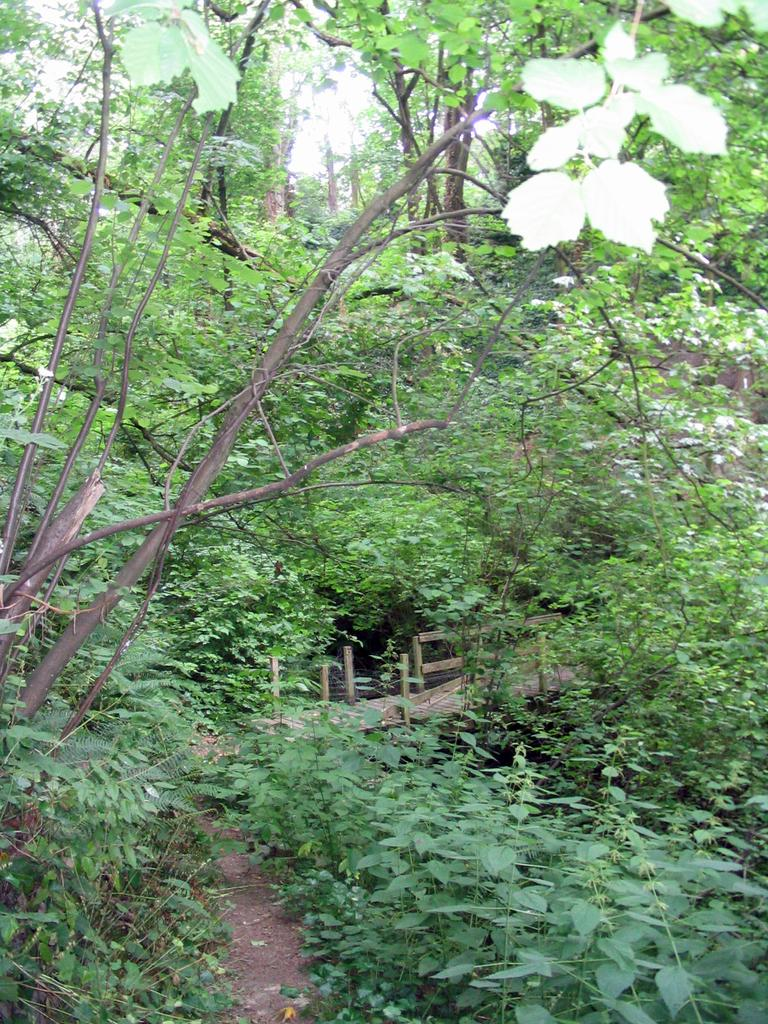What type of vegetation can be seen in the picture? There are trees and plants in the picture. Where is the wooden walkway located in the picture? The wooden walkway is in the picture. What color is the chicken's eye in the picture? There is no chicken or eye present in the picture. Can you describe the ocean in the picture? There is no ocean present in the picture. 